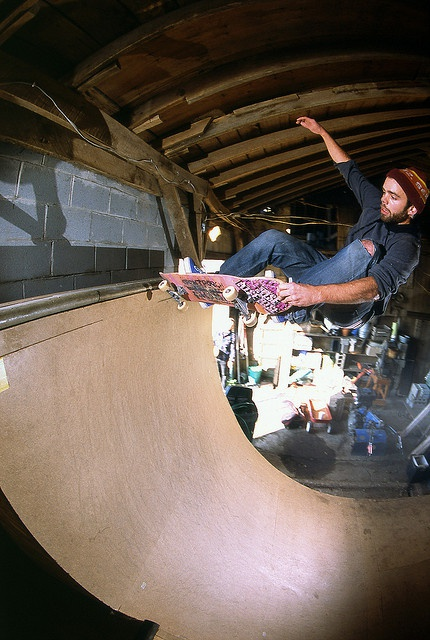Describe the objects in this image and their specific colors. I can see people in black and gray tones, skateboard in black, lavender, lightpink, gray, and brown tones, and people in black, white, gray, and darkgray tones in this image. 